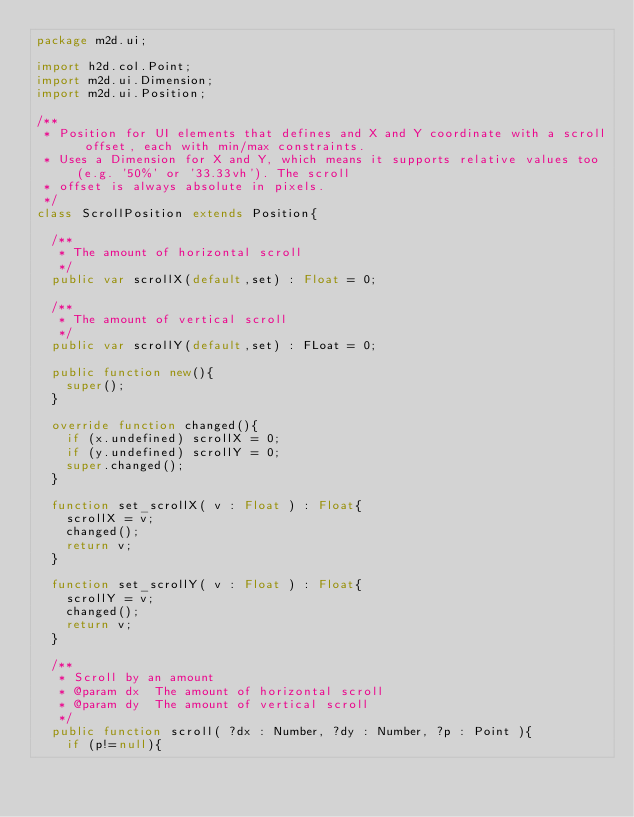<code> <loc_0><loc_0><loc_500><loc_500><_Haxe_>package m2d.ui;

import h2d.col.Point;
import m2d.ui.Dimension;
import m2d.ui.Position;

/**
 * Position for UI elements that defines and X and Y coordinate with a scroll offset, each with min/max constraints.
 * Uses a Dimension for X and Y, which means it supports relative values too (e.g. '50%' or '33.33vh'). The scroll
 * offset is always absolute in pixels.
 */
class ScrollPosition extends Position{

	/**
	 * The amount of horizontal scroll
	 */
	public var scrollX(default,set) : Float = 0;

	/**
	 * The amount of vertical scroll
	 */
	public var scrollY(default,set) : FLoat = 0;

	public function new(){
		super();
	}

	override function changed(){
		if (x.undefined) scrollX = 0;
		if (y.undefined) scrollY = 0;
		super.changed();
	}

	function set_scrollX( v : Float ) : Float{
		scrollX = v;
		changed();
		return v;
	}

	function set_scrollY( v : Float ) : Float{
		scrollY = v;
		changed();
		return v;
	}

	/**
	 * Scroll by an amount
	 * @param dx 	The amount of horizontal scroll
	 * @param dy 	The amount of vertical scroll
	 */
	public function scroll( ?dx : Number, ?dy : Number, ?p : Point ){
		if (p!=null){</code> 